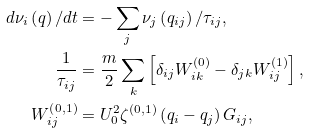<formula> <loc_0><loc_0><loc_500><loc_500>d \nu _ { i } \left ( q \right ) / d t & = - \sum _ { j } \nu _ { j } \left ( q _ { i j } \right ) / \tau _ { i j } , \\ \frac { 1 } { \tau _ { i j } } & = \frac { m } { 2 } \sum _ { k } \left [ \delta _ { i j } W _ { i k } ^ { \left ( 0 \right ) } - \delta _ { j k } W _ { i j } ^ { \left ( 1 \right ) } \right ] , \\ W _ { i j } ^ { \left ( 0 , 1 \right ) } & = U _ { 0 } ^ { 2 } \zeta ^ { \left ( 0 , 1 \right ) } \left ( q _ { i } - q _ { j } \right ) G _ { i j } ,</formula> 